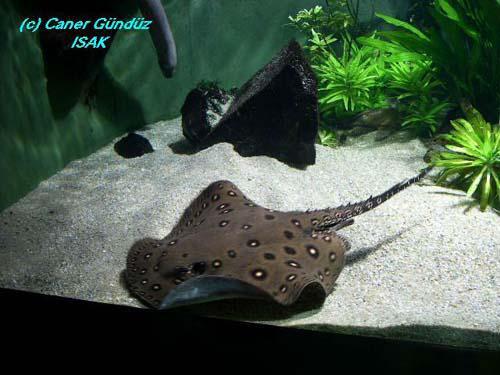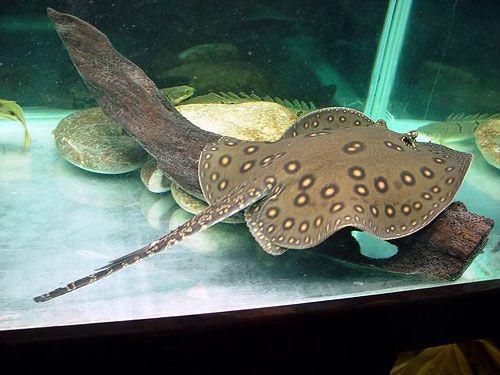The first image is the image on the left, the second image is the image on the right. Considering the images on both sides, is "There are exactly three stingrays." valid? Answer yes or no. No. 